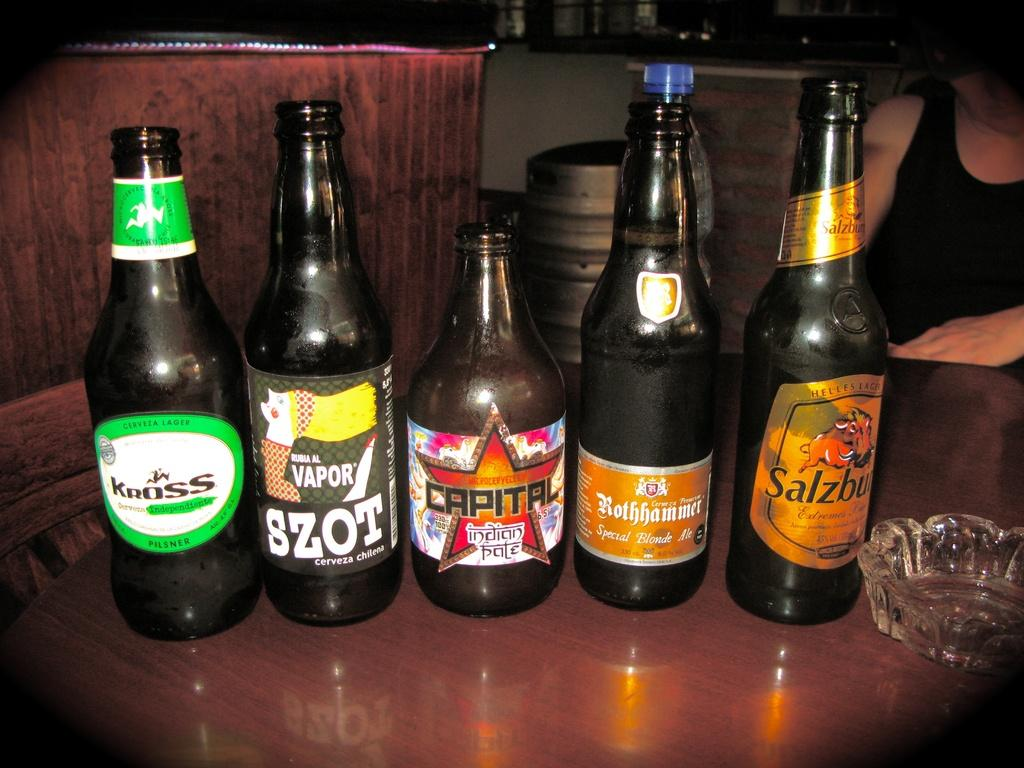<image>
Create a compact narrative representing the image presented. 5 bottles of beer next to each other with Capital indian pale in the middle 